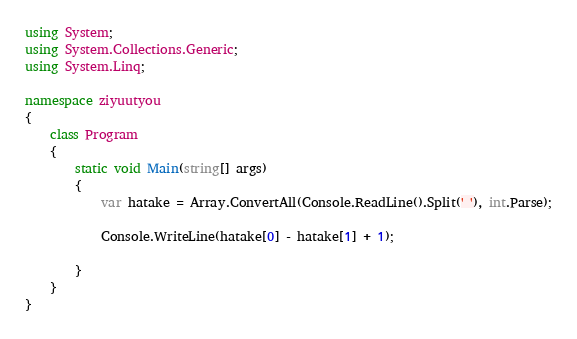<code> <loc_0><loc_0><loc_500><loc_500><_C#_>using System;
using System.Collections.Generic;
using System.Linq;

namespace ziyuutyou
{
    class Program
    {
        static void Main(string[] args)
        {
            var hatake = Array.ConvertAll(Console.ReadLine().Split(' '), int.Parse);

            Console.WriteLine(hatake[0] - hatake[1] + 1);
            
        }
    }
}
</code> 